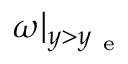Convert formula to latex. <formula><loc_0><loc_0><loc_500><loc_500>\omega | _ { y > y _ { e } }</formula> 